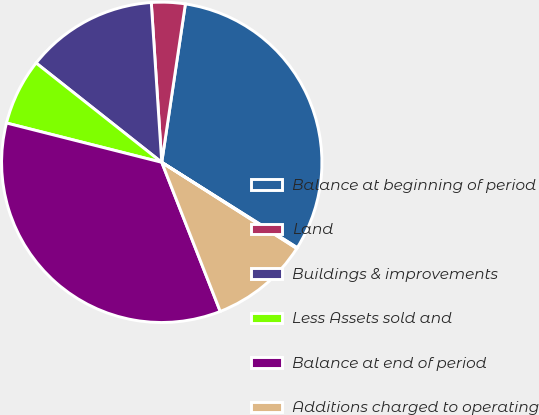Convert chart. <chart><loc_0><loc_0><loc_500><loc_500><pie_chart><fcel>Balance at beginning of period<fcel>Land<fcel>Buildings & improvements<fcel>Less Assets sold and<fcel>Balance at end of period<fcel>Additions charged to operating<fcel>Less Accumulated depreciation<nl><fcel>31.59%<fcel>3.4%<fcel>13.31%<fcel>6.7%<fcel>34.9%<fcel>10.01%<fcel>0.09%<nl></chart> 